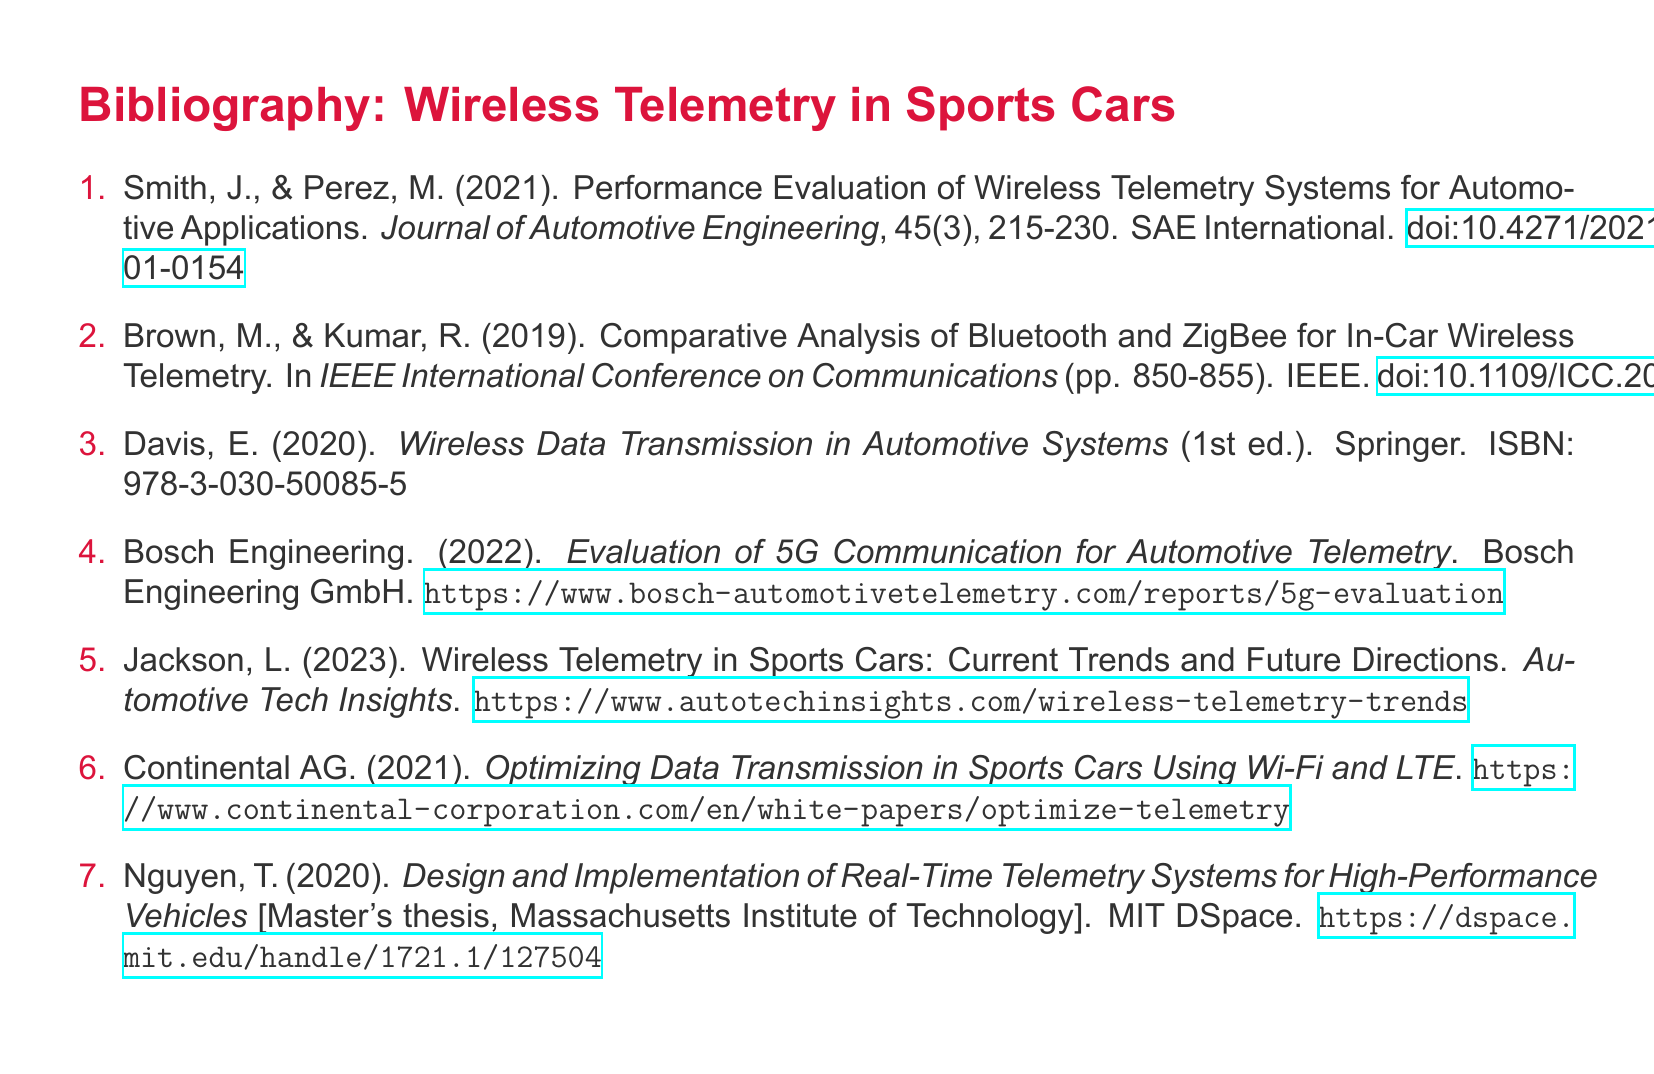What is the first author listed in the bibliography? The first author listed in the bibliography is Smith, J.
Answer: Smith, J What publication year is associated with the article on Bluetooth and ZigBee? The article on Bluetooth and ZigBee was published in 2019.
Answer: 2019 What type of document is authored by Davis, E.? The document authored by Davis, E. is a book.
Answer: book Which university is associated with Nguyen, T.'s master's thesis? Nguyen, T.'s master's thesis is associated with the Massachusetts Institute of Technology.
Answer: Massachusetts Institute of Technology What is the title of the document evaluated by Bosch Engineering? The title of the document evaluated by Bosch Engineering is Evaluation of 5G Communication for Automotive Telemetry.
Answer: Evaluation of 5G Communication for Automotive Telemetry Based on the bibliography, which communication method is evaluated alongside Wi-Fi? The communication method evaluated alongside Wi-Fi is LTE.
Answer: LTE How many total entries are in the bibliography? There are a total of seven entries in the bibliography.
Answer: seven What is the focus of Jackson, L.'s article? Jackson, L.'s article focuses on current trends and future directions of wireless telemetry in sports cars.
Answer: current trends and future directions of wireless telemetry in sports cars 